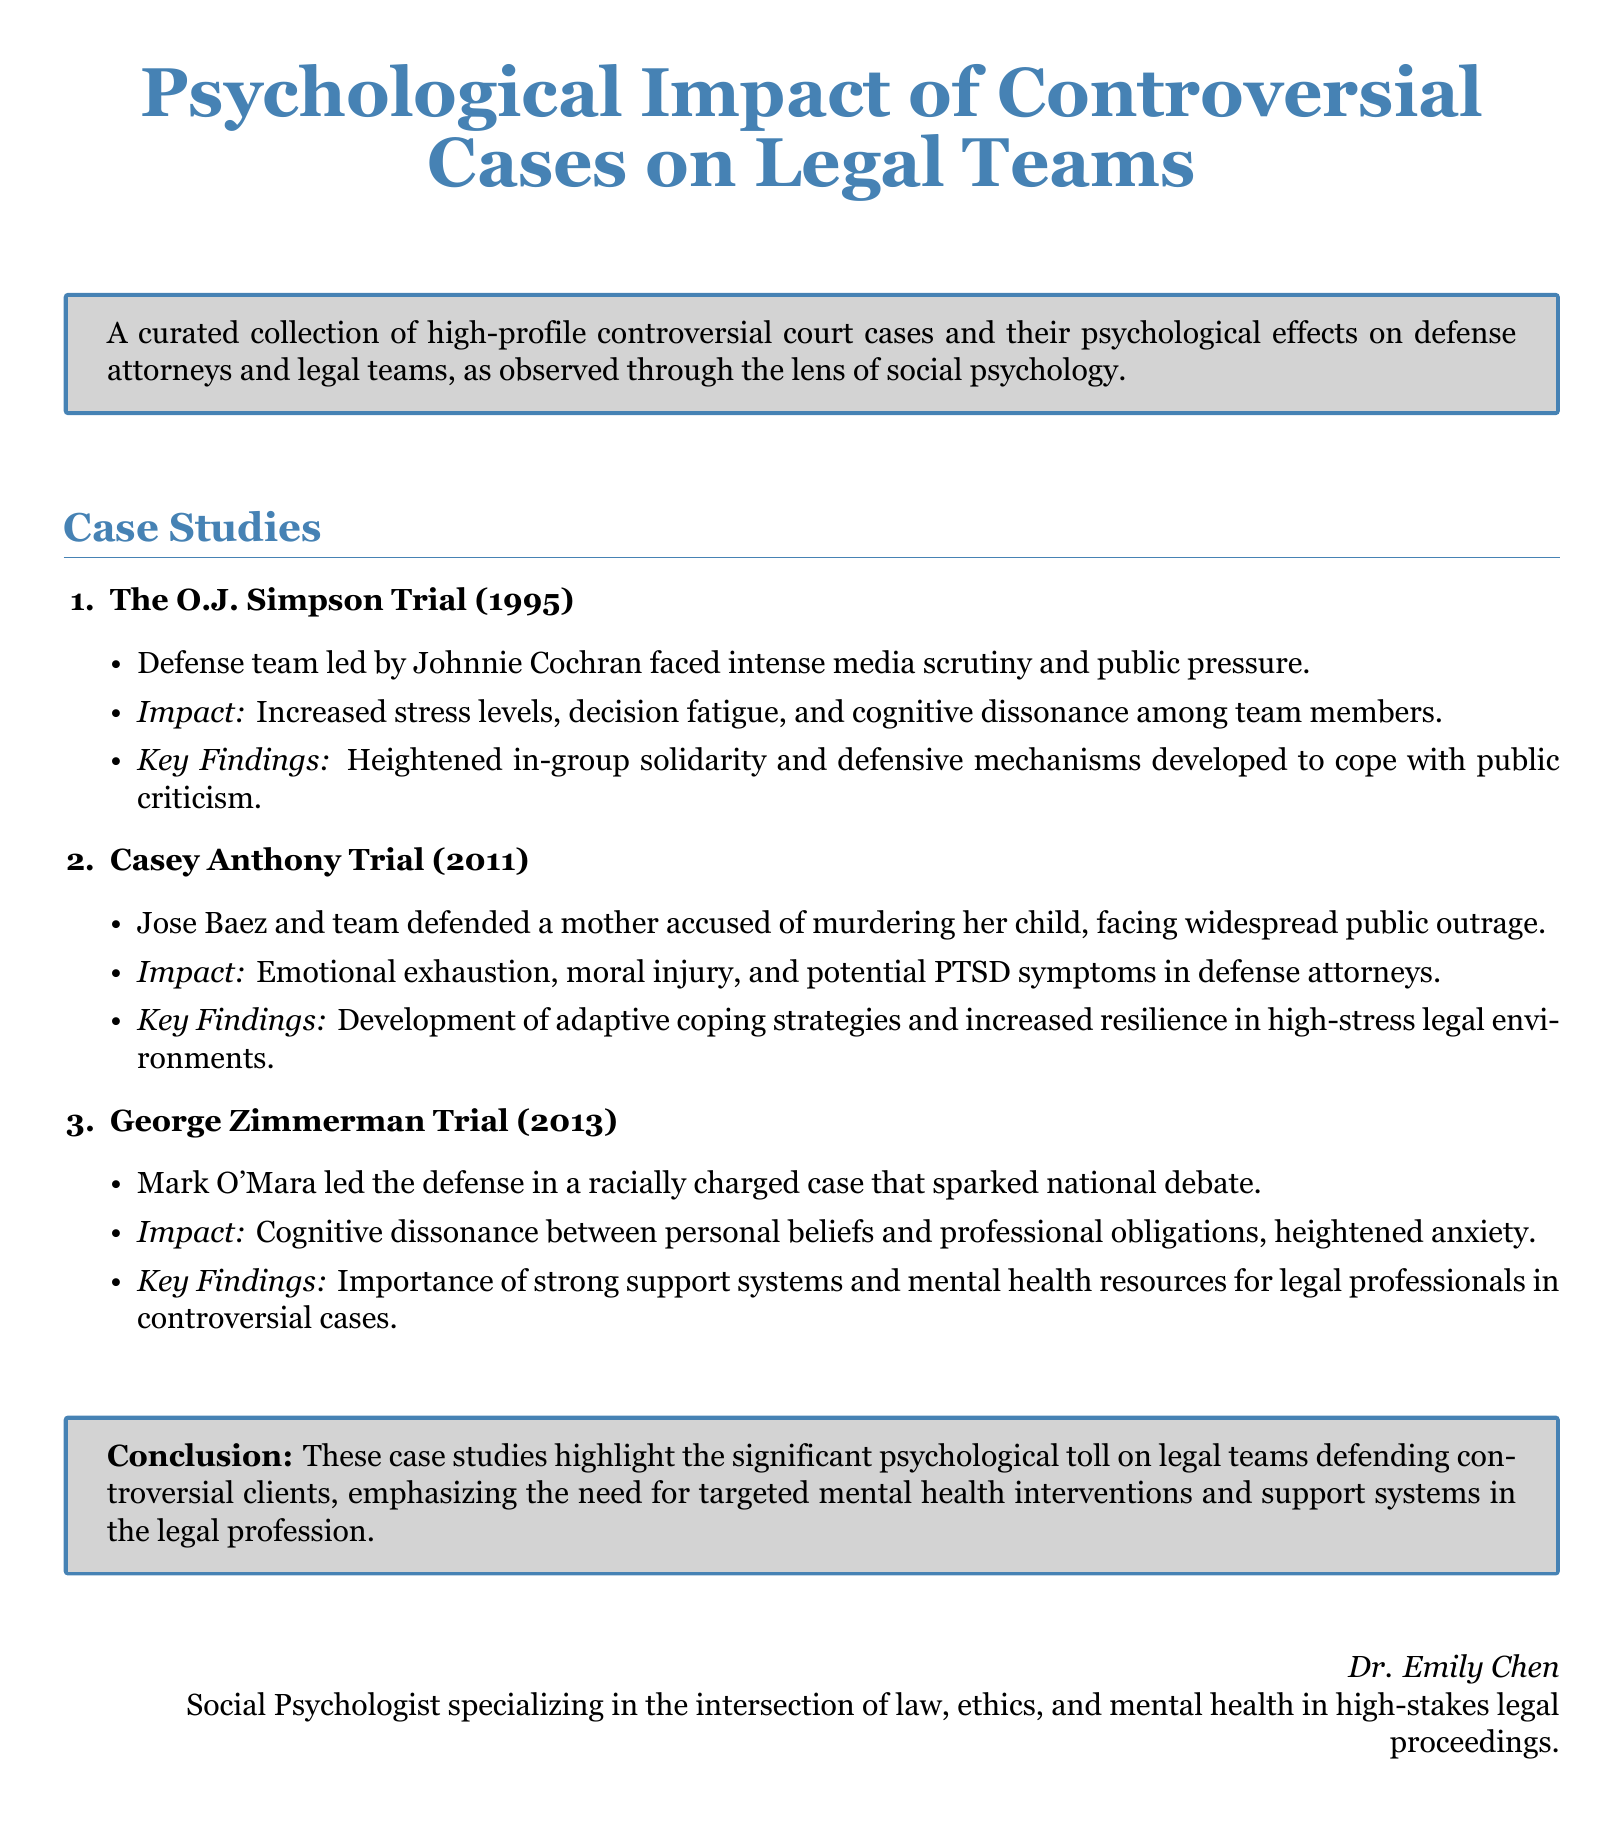What is the first case study mentioned? The first case study in the document is "The O.J. Simpson Trial (1995)."
Answer: The O.J. Simpson Trial (1995) What year did the Casey Anthony Trial take place? The document states that the Casey Anthony Trial occurred in 2011.
Answer: 2011 Who led the defense team in the George Zimmerman Trial? The defense team in the George Zimmerman Trial was led by Mark O'Mara.
Answer: Mark O'Mara What psychological impact was noted during the O.J. Simpson Trial? The document mentions increased stress levels, decision fatigue, and cognitive dissonance among team members as impacts.
Answer: Increased stress levels, decision fatigue, and cognitive dissonance What coping strategy developed in the Casey Anthony defense team? The document states that the Casey Anthony defense team developed adaptive coping strategies and increased resilience.
Answer: Adaptive coping strategies How does the document categorize the types of psychological tolls? The document highlights "emotional exhaustion, moral injury, and potential PTSD symptoms" as the psychological tolls experienced.
Answer: Emotional exhaustion, moral injury, and potential PTSD symptoms What is emphasized in the conclusion of the document? The conclusion emphasizes the need for targeted mental health interventions and support systems in the legal profession.
Answer: Targeted mental health interventions and support systems Who authored this document? The document attributes the authorship to Dr. Emily Chen, who specializes in the intersection of law, ethics, and mental health.
Answer: Dr. Emily Chen 